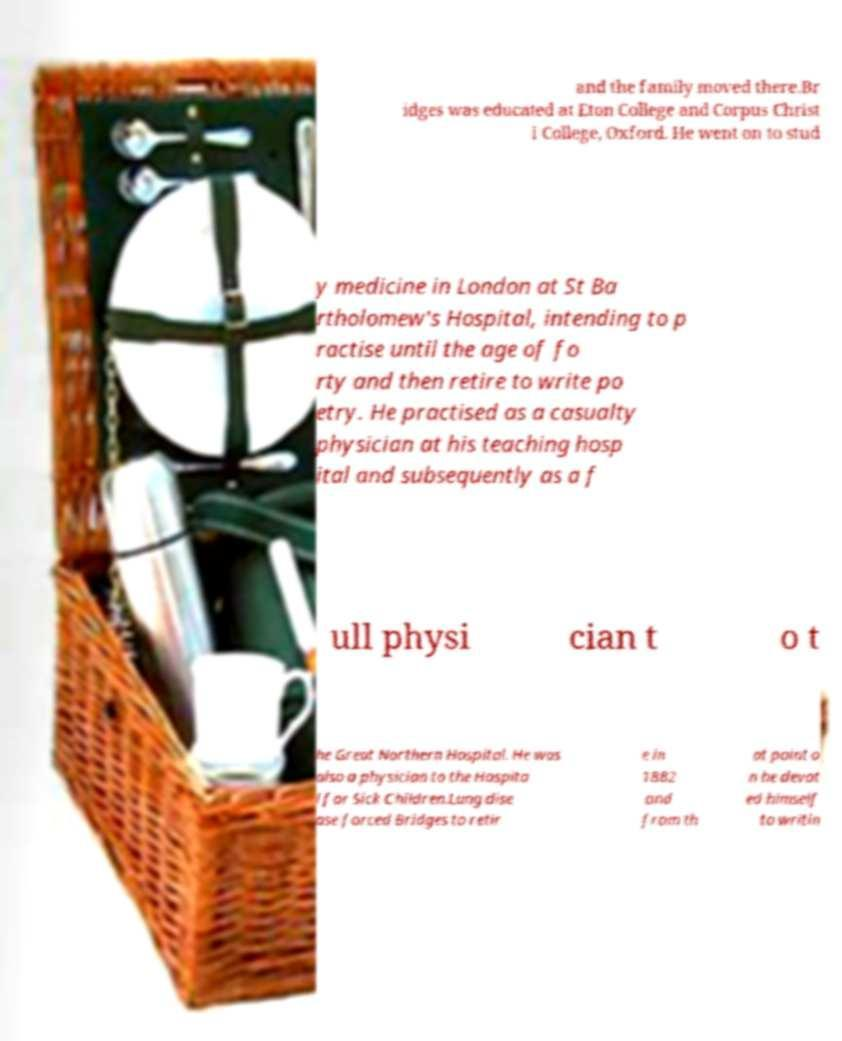I need the written content from this picture converted into text. Can you do that? and the family moved there.Br idges was educated at Eton College and Corpus Christ i College, Oxford. He went on to stud y medicine in London at St Ba rtholomew's Hospital, intending to p ractise until the age of fo rty and then retire to write po etry. He practised as a casualty physician at his teaching hosp ital and subsequently as a f ull physi cian t o t he Great Northern Hospital. He was also a physician to the Hospita l for Sick Children.Lung dise ase forced Bridges to retir e in 1882 and from th at point o n he devot ed himself to writin 